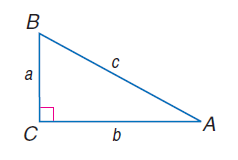Answer the mathemtical geometry problem and directly provide the correct option letter.
Question: a = 8, b = 15, and c = 17, find \cos B.
Choices: A: 0.43 B: 0.47 C: 0.53 D: 0.57 B 